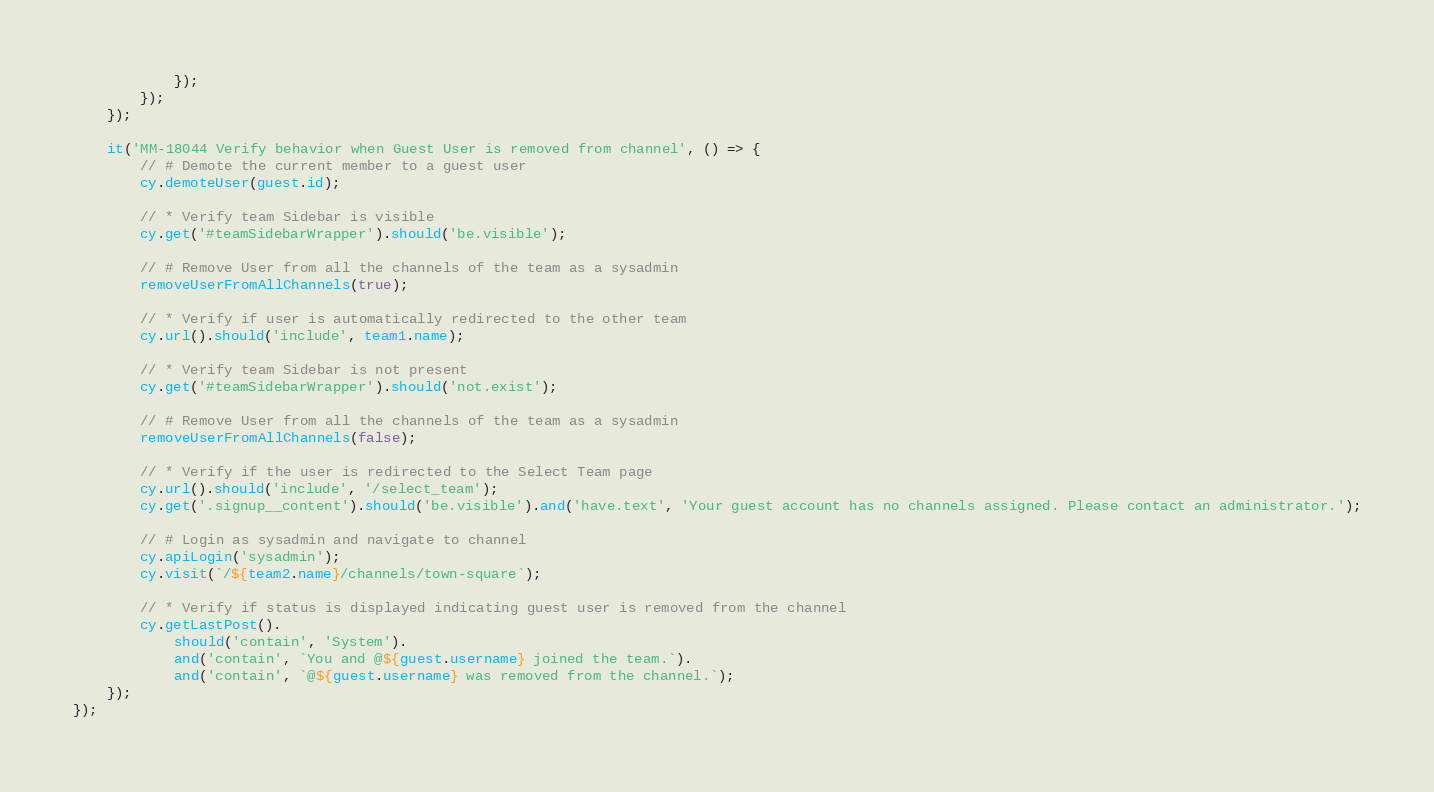<code> <loc_0><loc_0><loc_500><loc_500><_JavaScript_>            });
        });
    });

    it('MM-18044 Verify behavior when Guest User is removed from channel', () => {
        // # Demote the current member to a guest user
        cy.demoteUser(guest.id);

        // * Verify team Sidebar is visible
        cy.get('#teamSidebarWrapper').should('be.visible');

        // # Remove User from all the channels of the team as a sysadmin
        removeUserFromAllChannels(true);

        // * Verify if user is automatically redirected to the other team
        cy.url().should('include', team1.name);

        // * Verify team Sidebar is not present
        cy.get('#teamSidebarWrapper').should('not.exist');

        // # Remove User from all the channels of the team as a sysadmin
        removeUserFromAllChannels(false);

        // * Verify if the user is redirected to the Select Team page
        cy.url().should('include', '/select_team');
        cy.get('.signup__content').should('be.visible').and('have.text', 'Your guest account has no channels assigned. Please contact an administrator.');

        // # Login as sysadmin and navigate to channel
        cy.apiLogin('sysadmin');
        cy.visit(`/${team2.name}/channels/town-square`);

        // * Verify if status is displayed indicating guest user is removed from the channel
        cy.getLastPost().
            should('contain', 'System').
            and('contain', `You and @${guest.username} joined the team.`).
            and('contain', `@${guest.username} was removed from the channel.`);
    });
});
</code> 